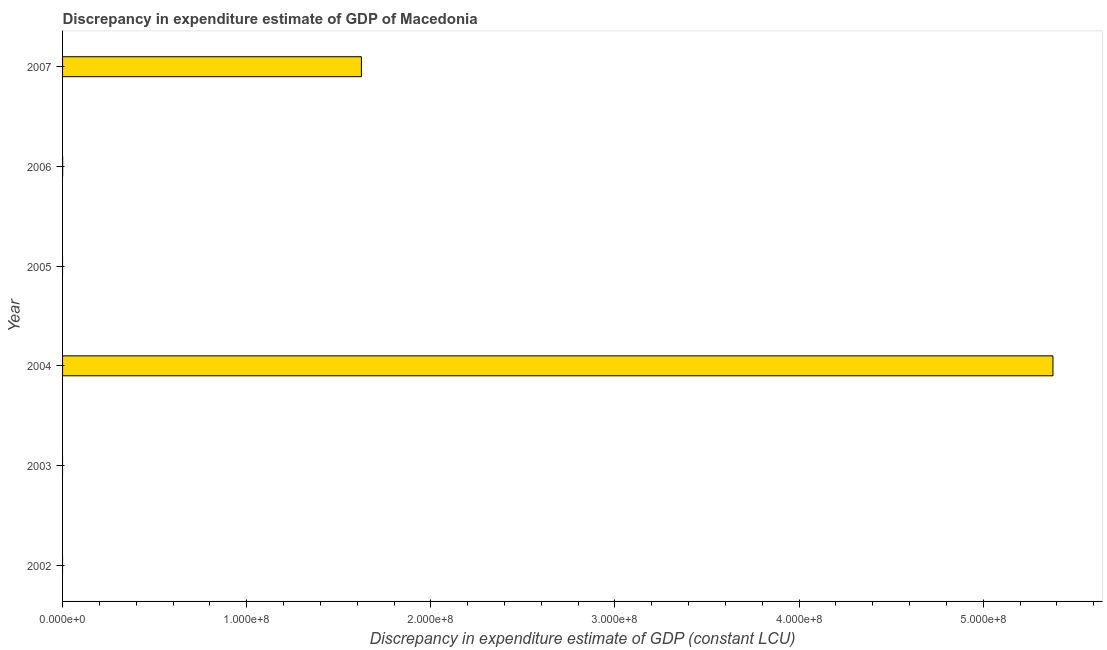What is the title of the graph?
Provide a succinct answer. Discrepancy in expenditure estimate of GDP of Macedonia. What is the label or title of the X-axis?
Offer a very short reply. Discrepancy in expenditure estimate of GDP (constant LCU). Across all years, what is the maximum discrepancy in expenditure estimate of gdp?
Offer a terse response. 5.38e+08. In which year was the discrepancy in expenditure estimate of gdp maximum?
Keep it short and to the point. 2004. What is the sum of the discrepancy in expenditure estimate of gdp?
Offer a very short reply. 7.00e+08. What is the difference between the discrepancy in expenditure estimate of gdp in 2004 and 2007?
Offer a very short reply. 3.76e+08. What is the average discrepancy in expenditure estimate of gdp per year?
Your response must be concise. 1.17e+08. What is the median discrepancy in expenditure estimate of gdp?
Give a very brief answer. 2.34e+04. In how many years, is the discrepancy in expenditure estimate of gdp greater than 360000000 LCU?
Ensure brevity in your answer.  1. What is the ratio of the discrepancy in expenditure estimate of gdp in 2004 to that in 2007?
Ensure brevity in your answer.  3.31. Is the difference between the discrepancy in expenditure estimate of gdp in 2004 and 2007 greater than the difference between any two years?
Offer a very short reply. No. What is the difference between the highest and the second highest discrepancy in expenditure estimate of gdp?
Ensure brevity in your answer.  3.76e+08. What is the difference between the highest and the lowest discrepancy in expenditure estimate of gdp?
Make the answer very short. 5.38e+08. How many bars are there?
Provide a short and direct response. 3. How many years are there in the graph?
Your answer should be compact. 6. What is the difference between two consecutive major ticks on the X-axis?
Provide a succinct answer. 1.00e+08. What is the Discrepancy in expenditure estimate of GDP (constant LCU) in 2003?
Your response must be concise. 0. What is the Discrepancy in expenditure estimate of GDP (constant LCU) in 2004?
Your response must be concise. 5.38e+08. What is the Discrepancy in expenditure estimate of GDP (constant LCU) in 2005?
Ensure brevity in your answer.  0. What is the Discrepancy in expenditure estimate of GDP (constant LCU) in 2006?
Your answer should be compact. 4.69e+04. What is the Discrepancy in expenditure estimate of GDP (constant LCU) of 2007?
Offer a very short reply. 1.62e+08. What is the difference between the Discrepancy in expenditure estimate of GDP (constant LCU) in 2004 and 2006?
Your response must be concise. 5.38e+08. What is the difference between the Discrepancy in expenditure estimate of GDP (constant LCU) in 2004 and 2007?
Your answer should be compact. 3.76e+08. What is the difference between the Discrepancy in expenditure estimate of GDP (constant LCU) in 2006 and 2007?
Make the answer very short. -1.62e+08. What is the ratio of the Discrepancy in expenditure estimate of GDP (constant LCU) in 2004 to that in 2006?
Your answer should be very brief. 1.15e+04. What is the ratio of the Discrepancy in expenditure estimate of GDP (constant LCU) in 2004 to that in 2007?
Give a very brief answer. 3.31. What is the ratio of the Discrepancy in expenditure estimate of GDP (constant LCU) in 2006 to that in 2007?
Your answer should be compact. 0. 